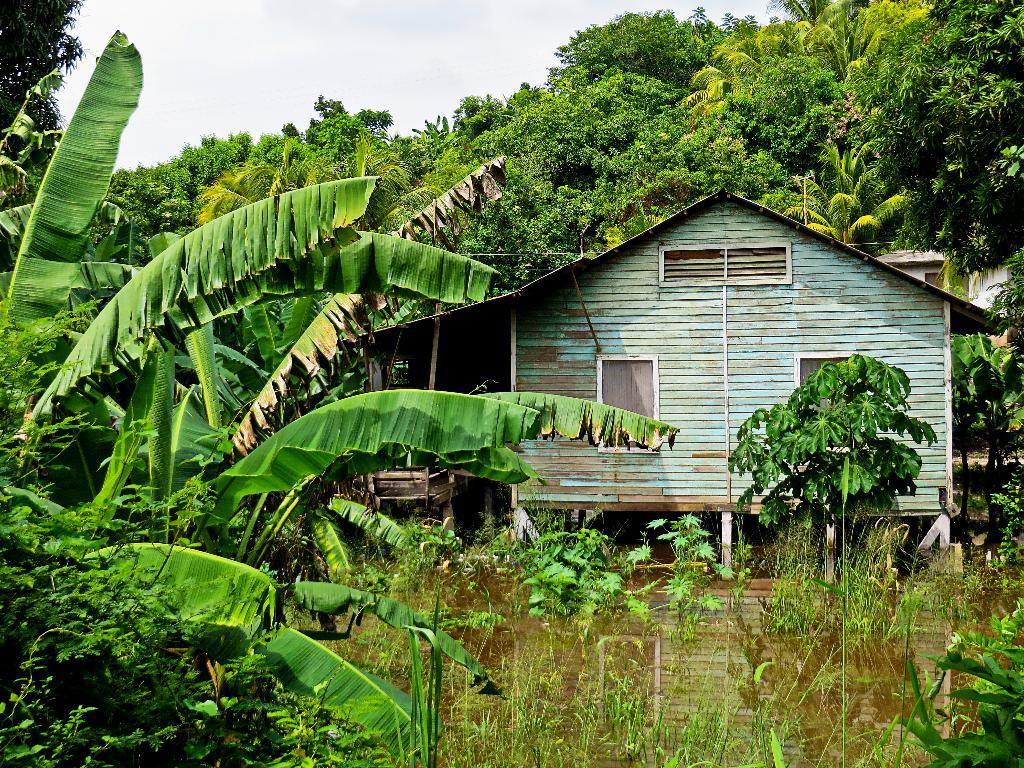What can be seen in the sky in the image? The sky is visible in the image. What type of natural elements are present in the image? There are trees and plants in the image. What type of structures can be seen in the image? There is a building and a wooden house in the image. What is the water doing in the image? The water is present in the image, and the reflection of the wooden house is visible on it. How does the image become quieter over time? The image is a still picture and does not have any sound or change over time, so it cannot become quieter. 